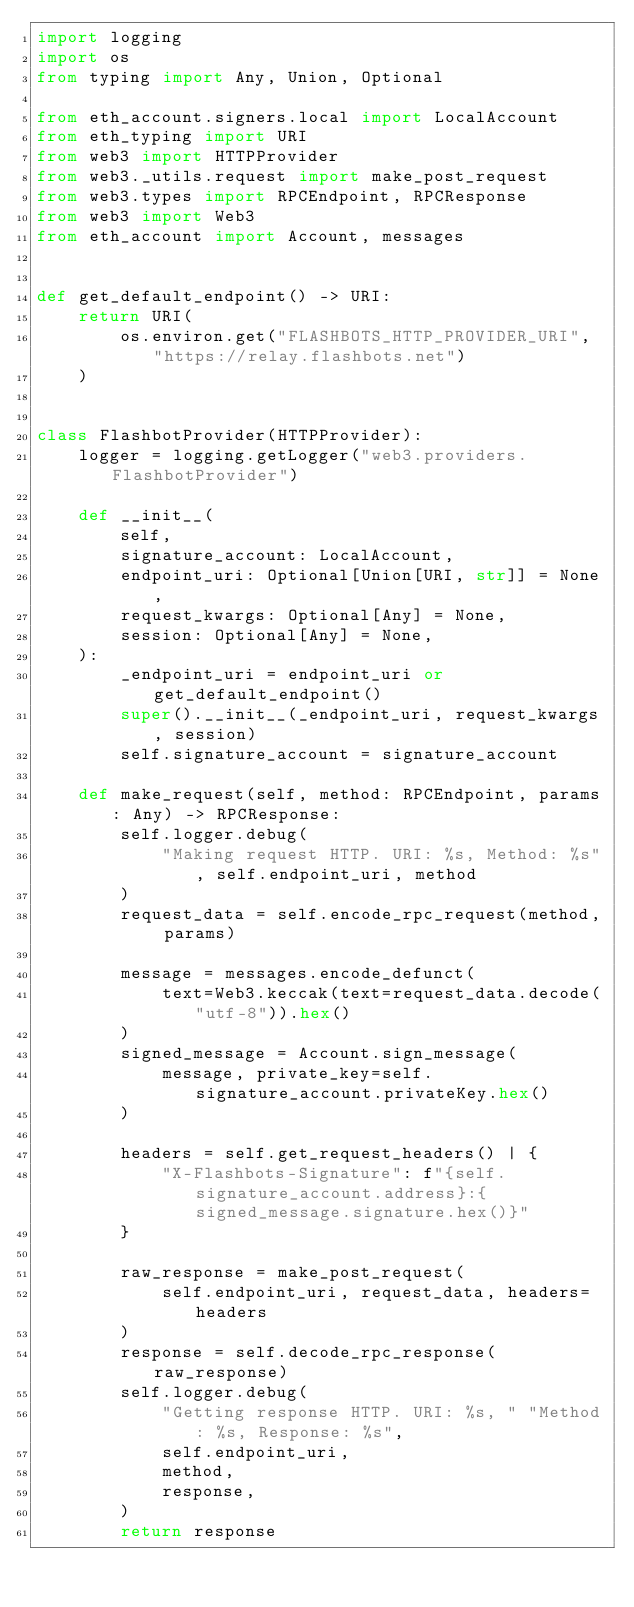Convert code to text. <code><loc_0><loc_0><loc_500><loc_500><_Python_>import logging
import os
from typing import Any, Union, Optional

from eth_account.signers.local import LocalAccount
from eth_typing import URI
from web3 import HTTPProvider
from web3._utils.request import make_post_request
from web3.types import RPCEndpoint, RPCResponse
from web3 import Web3
from eth_account import Account, messages


def get_default_endpoint() -> URI:
    return URI(
        os.environ.get("FLASHBOTS_HTTP_PROVIDER_URI", "https://relay.flashbots.net")
    )


class FlashbotProvider(HTTPProvider):
    logger = logging.getLogger("web3.providers.FlashbotProvider")

    def __init__(
        self,
        signature_account: LocalAccount,
        endpoint_uri: Optional[Union[URI, str]] = None,
        request_kwargs: Optional[Any] = None,
        session: Optional[Any] = None,
    ):
        _endpoint_uri = endpoint_uri or get_default_endpoint()
        super().__init__(_endpoint_uri, request_kwargs, session)
        self.signature_account = signature_account

    def make_request(self, method: RPCEndpoint, params: Any) -> RPCResponse:
        self.logger.debug(
            "Making request HTTP. URI: %s, Method: %s", self.endpoint_uri, method
        )
        request_data = self.encode_rpc_request(method, params)

        message = messages.encode_defunct(
            text=Web3.keccak(text=request_data.decode("utf-8")).hex()
        )
        signed_message = Account.sign_message(
            message, private_key=self.signature_account.privateKey.hex()
        )

        headers = self.get_request_headers() | {
            "X-Flashbots-Signature": f"{self.signature_account.address}:{signed_message.signature.hex()}"
        }

        raw_response = make_post_request(
            self.endpoint_uri, request_data, headers=headers
        )
        response = self.decode_rpc_response(raw_response)
        self.logger.debug(
            "Getting response HTTP. URI: %s, " "Method: %s, Response: %s",
            self.endpoint_uri,
            method,
            response,
        )
        return response
</code> 